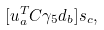<formula> <loc_0><loc_0><loc_500><loc_500>[ u _ { a } ^ { T } C \gamma _ { 5 } d _ { b } ] s _ { c } ,</formula> 